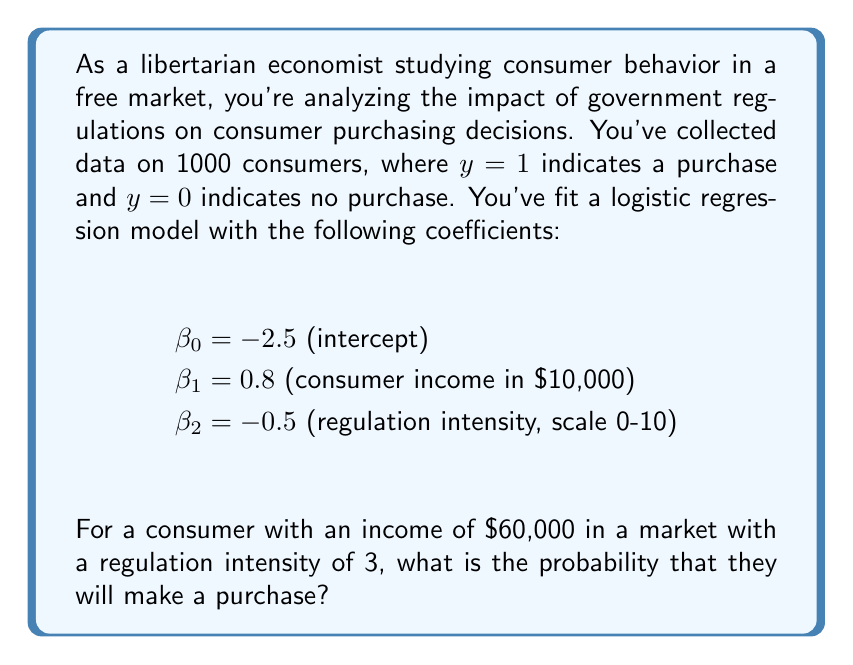Help me with this question. To solve this problem, we'll use the logistic regression model to calculate the probability of purchase. The steps are as follows:

1) The logistic regression model uses the logistic function:

   $P(y=1) = \frac{1}{1 + e^{-z}}$

   where $z = \beta_0 + \beta_1x_1 + \beta_2x_2 + ... + \beta_nx_n$

2) In this case, we have:
   $z = \beta_0 + \beta_1(\text{income}) + \beta_2(\text{regulation intensity})$

3) Let's substitute the values:
   - $\beta_0 = -2.5$
   - $\beta_1 = 0.8$, and income is $60,000 / 10,000 = 6$
   - $\beta_2 = -0.5$, and regulation intensity is 3

4) Calculate $z$:
   $z = -2.5 + 0.8(6) + (-0.5)(3)$
   $z = -2.5 + 4.8 - 1.5$
   $z = 0.8$

5) Now, we can calculate the probability:

   $P(y=1) = \frac{1}{1 + e^{-0.8}}$

6) Using a calculator or programming language to evaluate this:

   $P(y=1) \approx 0.6900$

Therefore, the probability that this consumer will make a purchase is approximately 0.6900 or 69.00%.
Answer: 0.6900 (or 69.00%) 